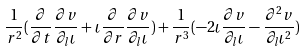Convert formula to latex. <formula><loc_0><loc_0><loc_500><loc_500>\frac { 1 } { r ^ { 2 } } ( \frac { \partial } { \partial t } \frac { \partial v } { \partial _ { l } \iota } + \iota \frac { \partial } { \partial r } \frac { \partial v } { \partial _ { l } \iota } ) + \frac { 1 } { r ^ { 3 } } ( - 2 \iota \frac { \partial v } { \partial _ { l } \iota } - \frac { \partial ^ { 2 } v } { \partial _ { l } \iota ^ { 2 } } )</formula> 